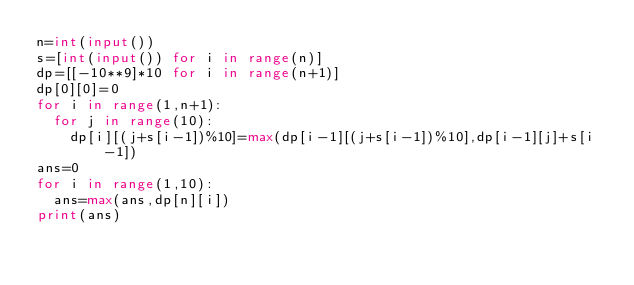Convert code to text. <code><loc_0><loc_0><loc_500><loc_500><_Python_>n=int(input())
s=[int(input()) for i in range(n)]
dp=[[-10**9]*10 for i in range(n+1)]
dp[0][0]=0
for i in range(1,n+1):
  for j in range(10):
    dp[i][(j+s[i-1])%10]=max(dp[i-1][(j+s[i-1])%10],dp[i-1][j]+s[i-1])
ans=0
for i in range(1,10):
  ans=max(ans,dp[n][i])
print(ans)</code> 